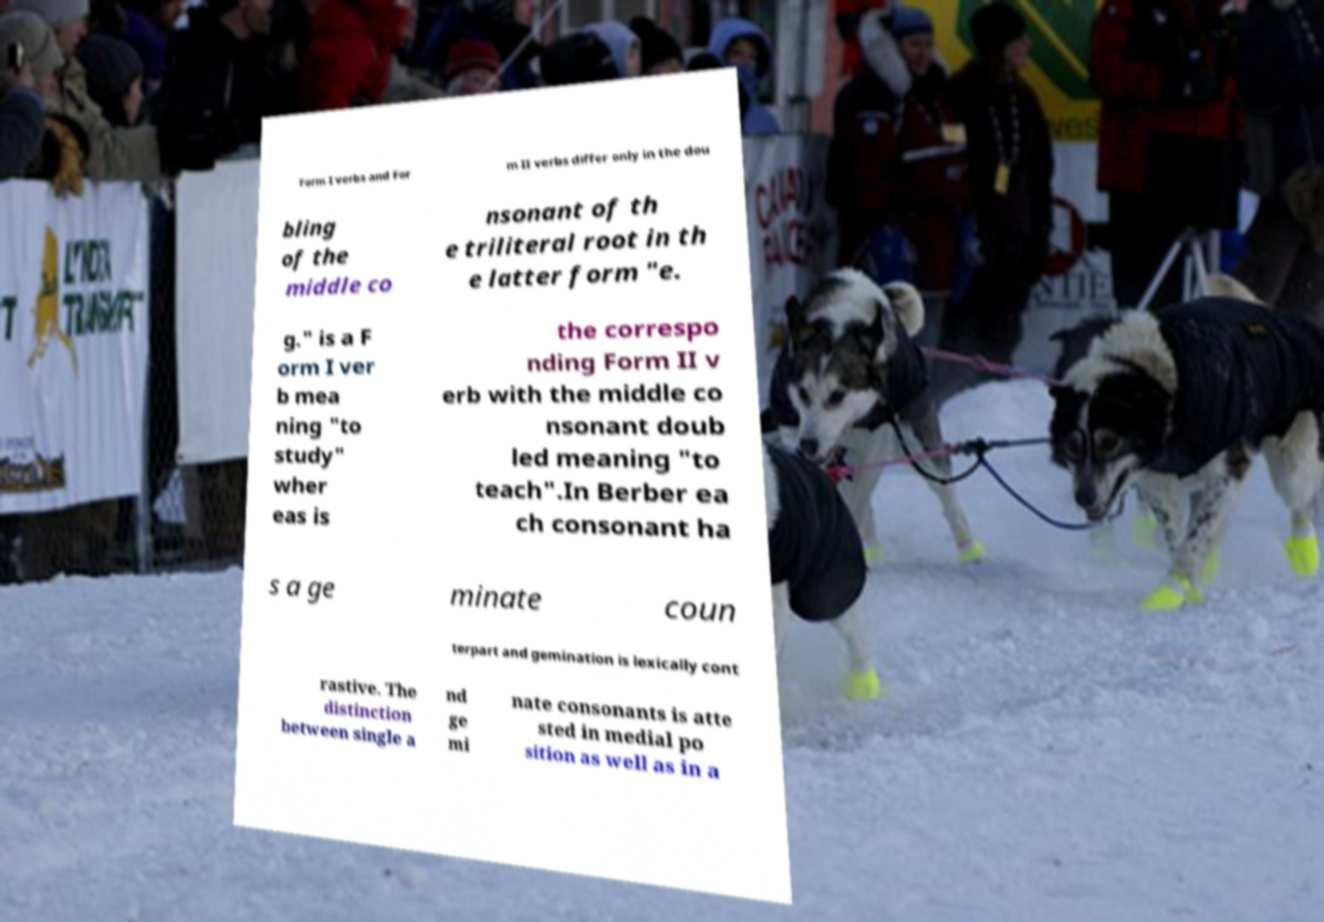I need the written content from this picture converted into text. Can you do that? Form I verbs and For m II verbs differ only in the dou bling of the middle co nsonant of th e triliteral root in th e latter form "e. g." is a F orm I ver b mea ning "to study" wher eas is the correspo nding Form II v erb with the middle co nsonant doub led meaning "to teach".In Berber ea ch consonant ha s a ge minate coun terpart and gemination is lexically cont rastive. The distinction between single a nd ge mi nate consonants is atte sted in medial po sition as well as in a 